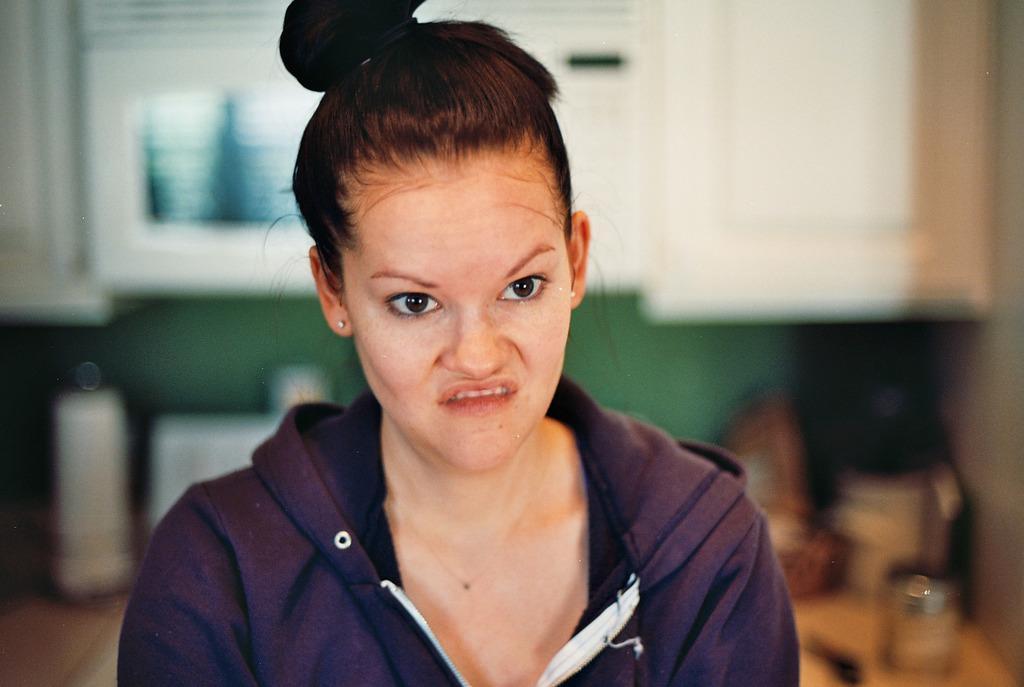Can you describe this image briefly? In the center of the image a lady is there. In the background of the image we can see some objects, wall, cupboard are present. At the bottom left corner floor is there. 